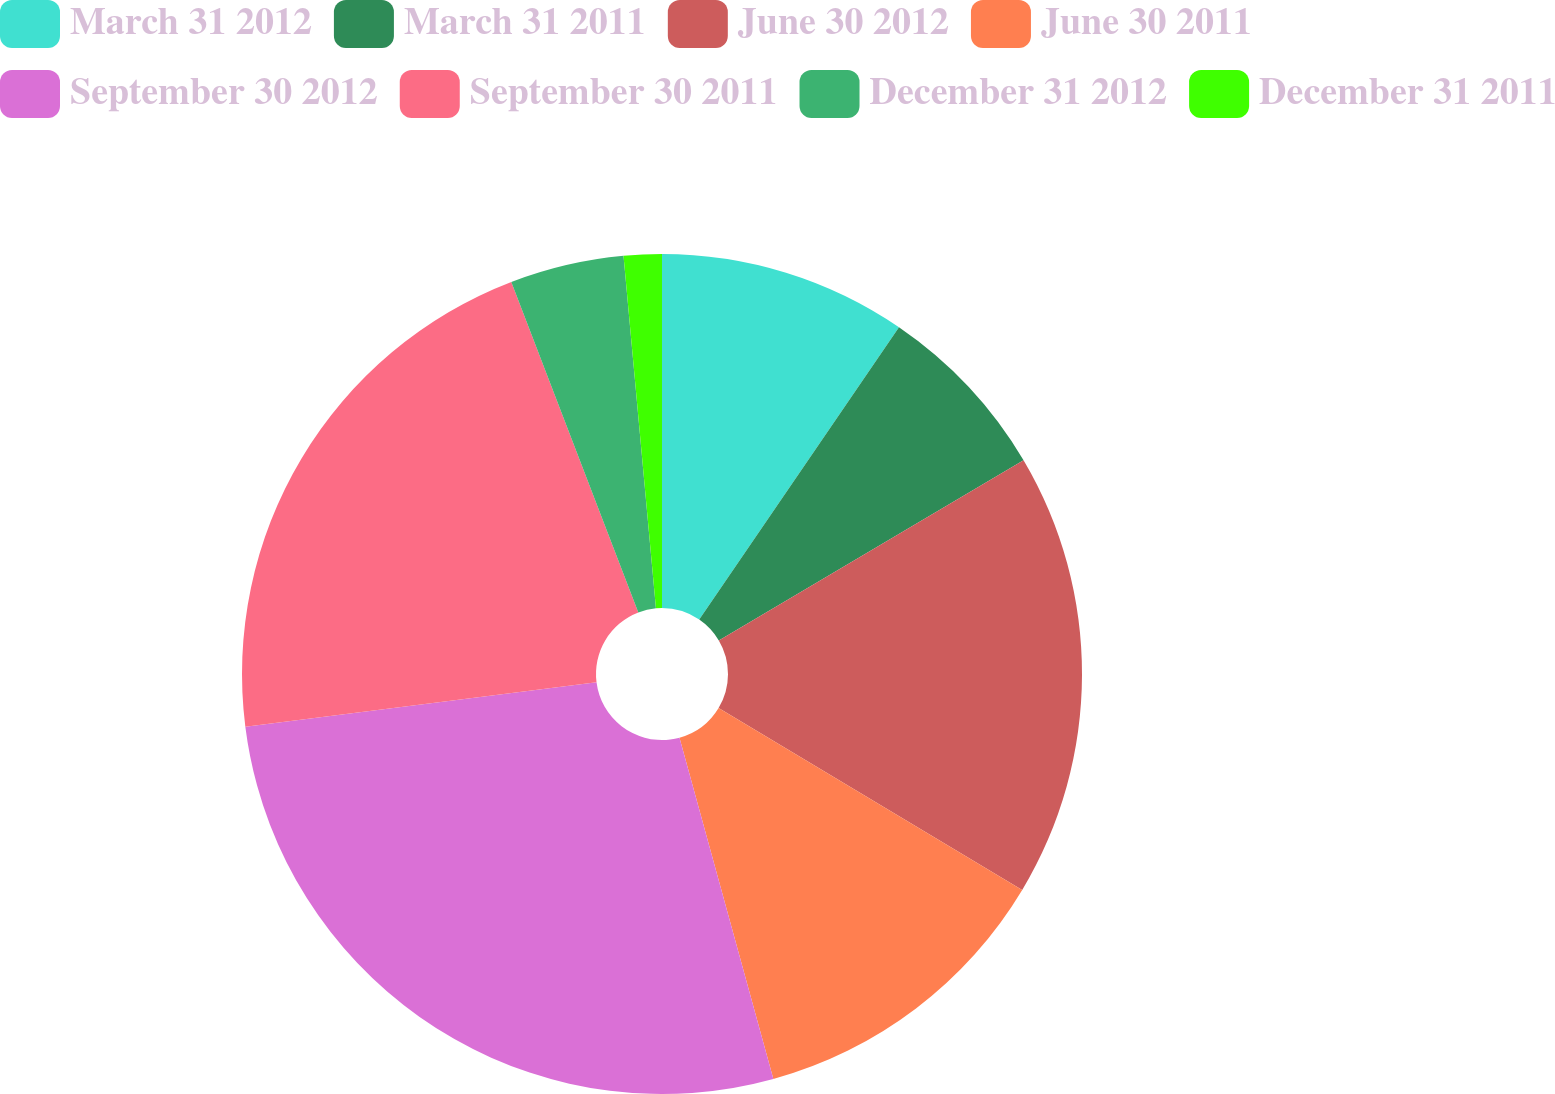Convert chart to OTSL. <chart><loc_0><loc_0><loc_500><loc_500><pie_chart><fcel>March 31 2012<fcel>March 31 2011<fcel>June 30 2012<fcel>June 30 2011<fcel>September 30 2012<fcel>September 30 2011<fcel>December 31 2012<fcel>December 31 2011<nl><fcel>9.54%<fcel>6.96%<fcel>17.09%<fcel>12.13%<fcel>27.26%<fcel>21.16%<fcel>4.38%<fcel>1.46%<nl></chart> 